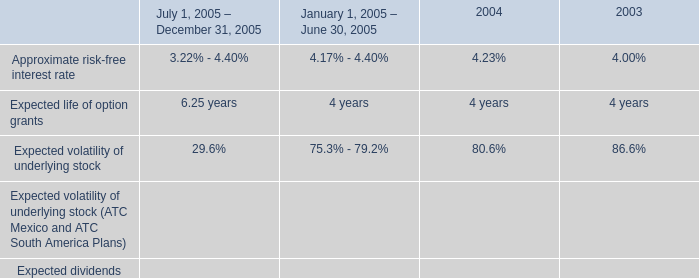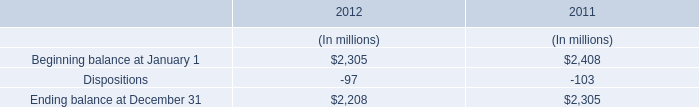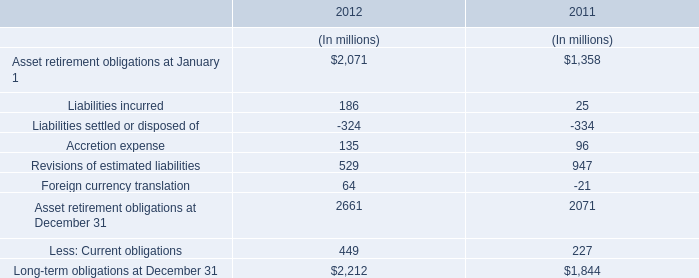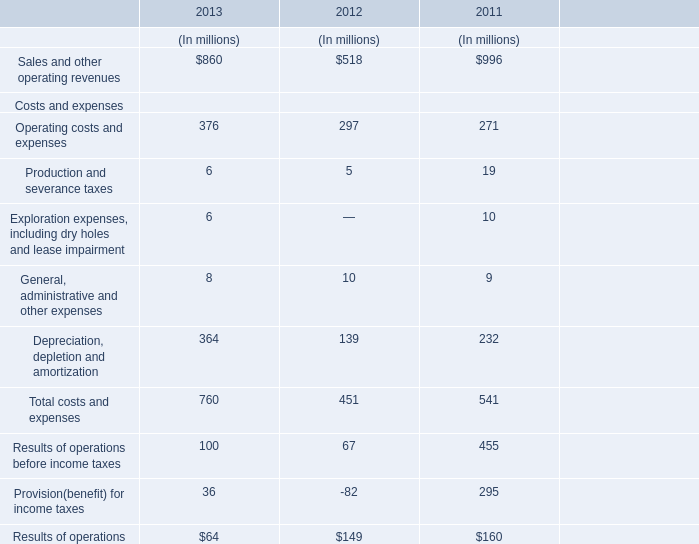What is the growing rate of the Total costs and expenses in the year with the least Sales and other operating revenues? 
Computations: ((451 - 541) / 541)
Answer: -0.16636. 